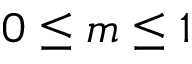<formula> <loc_0><loc_0><loc_500><loc_500>0 \leq m \leq 1</formula> 